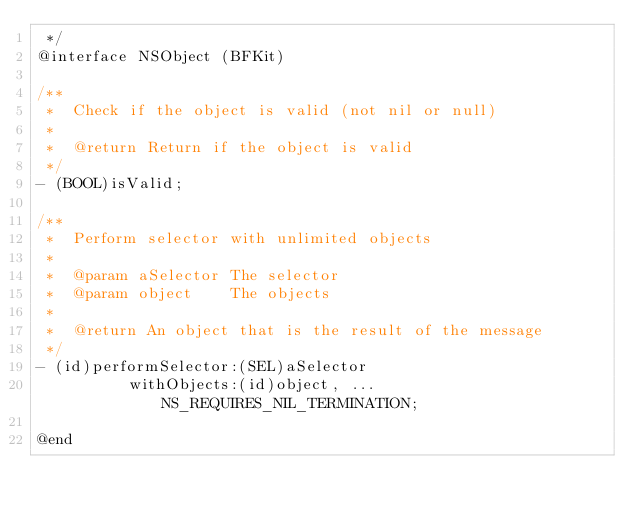<code> <loc_0><loc_0><loc_500><loc_500><_C_> */
@interface NSObject (BFKit)

/**
 *  Check if the object is valid (not nil or null)
 *
 *  @return Return if the object is valid
 */
- (BOOL)isValid;

/**
 *  Perform selector with unlimited objects
 *
 *  @param aSelector The selector
 *  @param object    The objects
 *
 *  @return An object that is the result of the message
 */
- (id)performSelector:(SEL)aSelector
          withObjects:(id)object, ... NS_REQUIRES_NIL_TERMINATION;

@end
</code> 